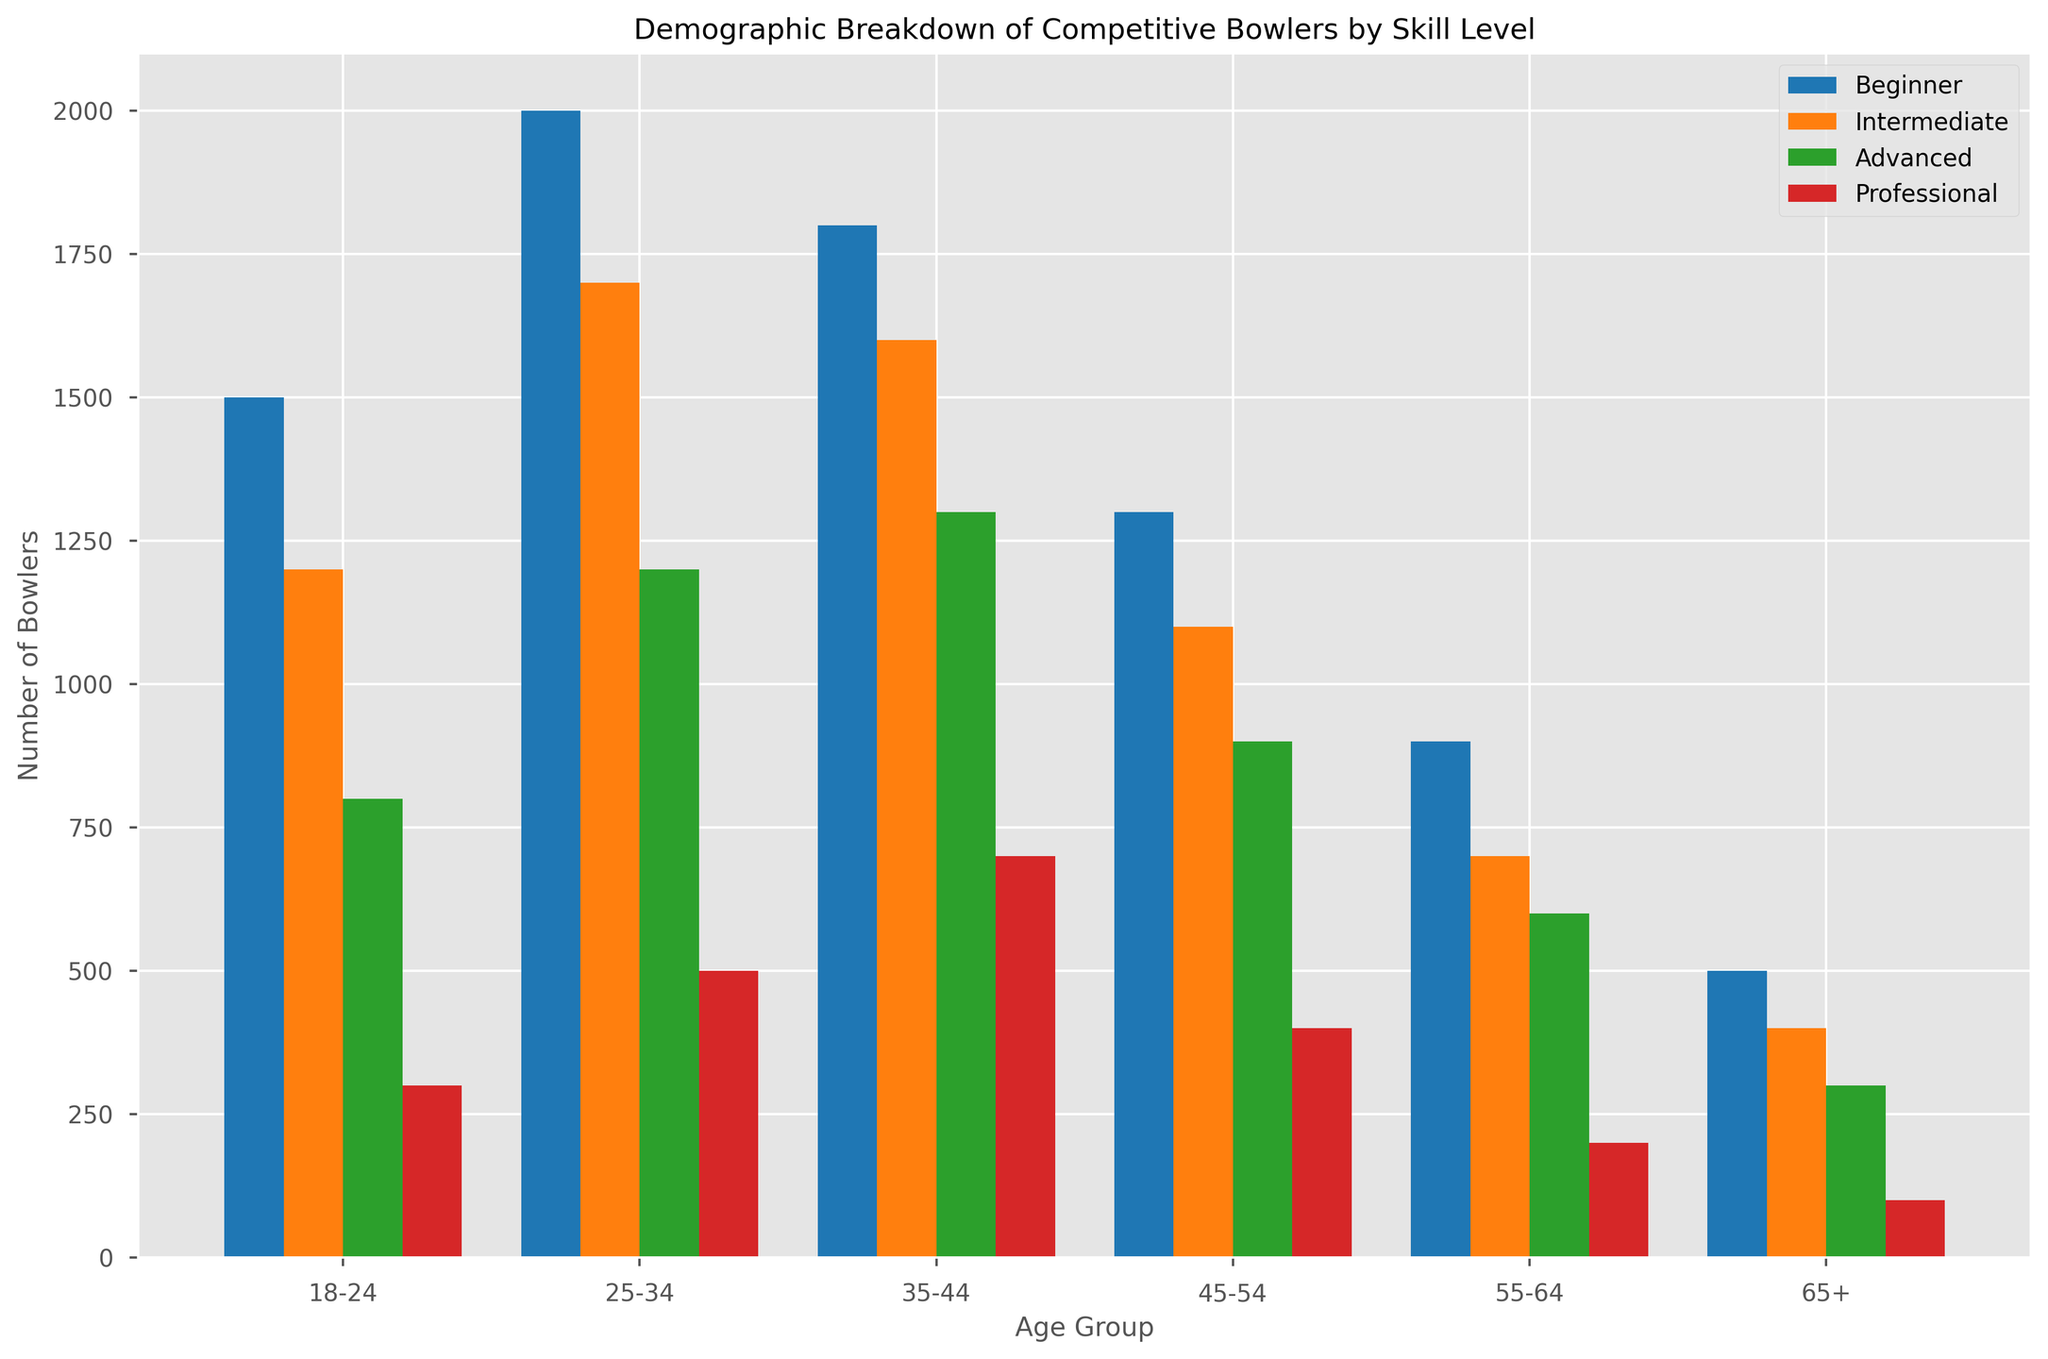Which skill level has the highest number of bowlers across the 18-24 age group? By examining the heights of the bars in the 18-24 age group, the bar representing beginners is the highest compared to other skill levels.
Answer: Beginner Which age group has the fewest professional bowlers? By looking at the heights of the red bars representing professionals, the 65+ age group has the shortest bar.
Answer: 65+ How does the number of advanced bowlers aged 25-34 compare to those aged 45-54? By comparing the heights of the green bars, you can see that the bar for 25-34 is slightly higher than the bar for 45-54 in the advanced skill level.
Answer: Higher What is the total number of intermediate bowlers in all age groups combined? Sum all the counts for the intermediate skill level: 1200 + 1700 + 1600 + 1100 + 700 + 400 = 6700.
Answer: 6700 Which age group shows the biggest drop in the number of bowlers from beginners to intermediate skill level? Calculate the difference in counts for each age group:  
18-24: 1500 - 1200 = 300  
25-34: 2000 - 1700 = 300  
35-44: 1800 - 1600 = 200  
45-54: 1300 - 1100 = 200  
55-64: 900 - 700 = 200  
65+: 500 - 400 = 100  
The biggest drop is in the 18-24 and 25-34 age groups with a difference of 300 each.
Answer: 18-24 and 25-34 What is the average number of beginner bowlers in the age groups under 35? Sum the counts and divide by the number of age groups: (1500 + 2000) / 2 = 3500 / 2 = 1750.
Answer: 1750 Is the count of professional bowlers higher in the 35-44 age group than the 25-34 age group? Compare the heights of the red bars for 35-44 and 25-34 age groups, and the height of 35-44 is higher.
Answer: Yes What is the ratio of beginner bowlers to professional bowlers in the 45-54 age group? Divide the number of beginner bowlers by the number of professional bowlers: 1300 / 400 = 3.25.
Answer: 3.25 Which skill level has the most even distribution across all age groups? By visually comparing the relative heights of the bars across all age groups, the intermediate skill level bars show the most even distribution.
Answer: Intermediate What's the total number of bowlers in the 55-64 age group across all skill levels? Sum the counts for the 55-64 age group across all skill levels: 900 (Beginner) + 700 (Intermediate) + 600 (Advanced) + 200 (Professional) = 2400.
Answer: 2400 